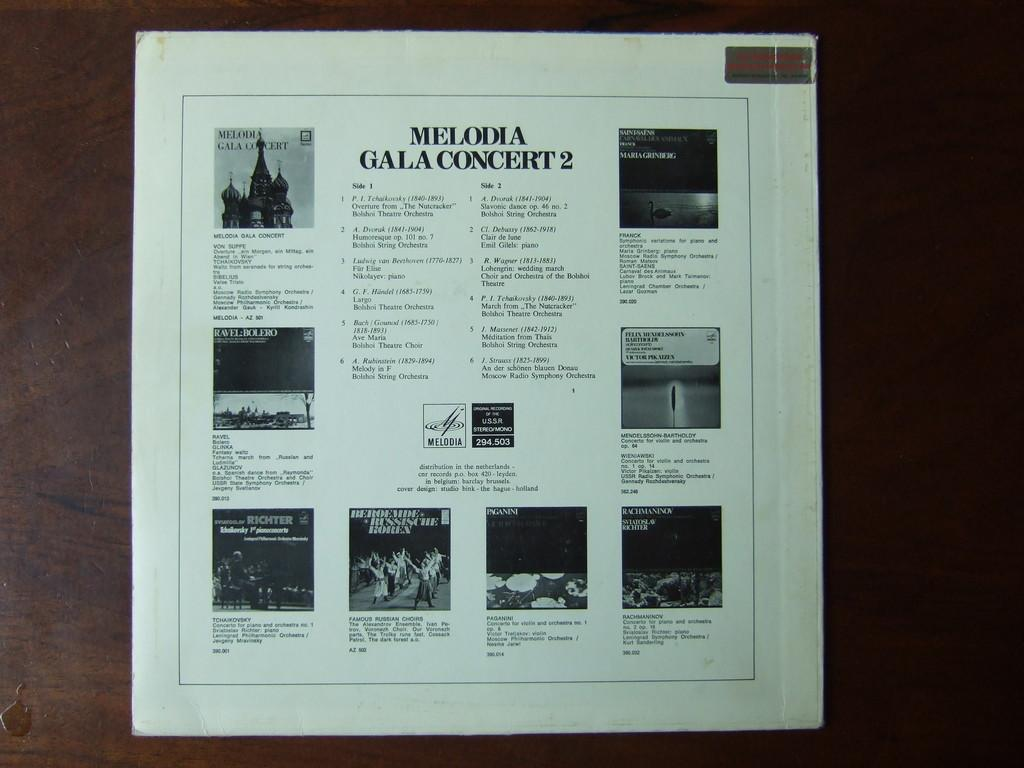Provide a one-sentence caption for the provided image. The back side of the record Melodia Gala Concert 2. 